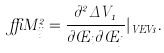<formula> <loc_0><loc_0><loc_500><loc_500>\delta M ^ { 2 } _ { i j } = \frac { \partial ^ { 2 } \Delta V _ { 1 } } { \partial \phi _ { i } \partial \phi _ { j } } | _ { V E V s } .</formula> 